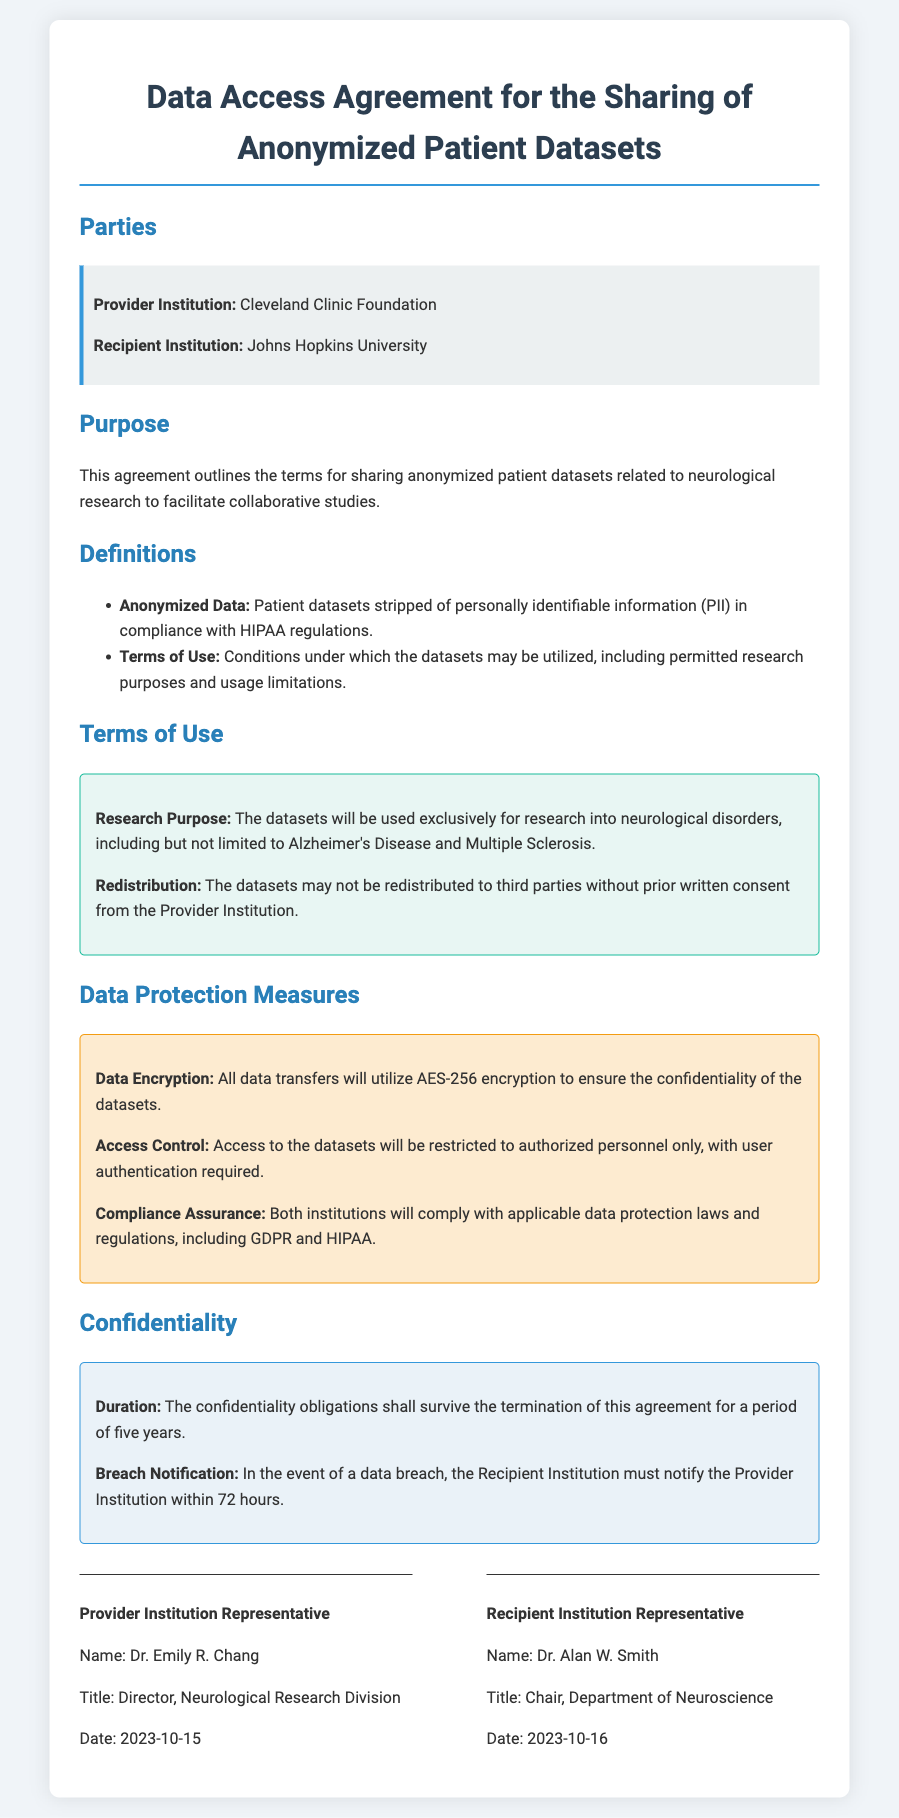What is the Provider Institution? The document identifies the organization providing the datasets as the Cleveland Clinic Foundation.
Answer: Cleveland Clinic Foundation Who is the Recipient Institution? The document specifies the organization receiving the datasets as Johns Hopkins University.
Answer: Johns Hopkins University What is the research purpose for the datasets? The document states that the datasets will be used exclusively for research into neurological disorders, including Alzheimer's Disease and Multiple Sclerosis.
Answer: Neurological disorders What is the encryption method used for data transfers? The document indicates that AES-256 encryption will be used to ensure confidentiality during data transfers.
Answer: AES-256 What is the duration of the confidentiality obligations? The document outlines that confidentiality obligations will last for a period of five years after the termination of the agreement.
Answer: Five years Who represents the Provider Institution? The document names Dr. Emily R. Chang as the representative for the Provider Institution along with her title.
Answer: Dr. Emily R. Chang When was the agreement signed by the Provider Institution representative? The document specifies that Dr. Emily R. Chang signed the agreement on the date 2023-10-15.
Answer: 2023-10-15 What must the Recipient Institution do in the event of a data breach? The document states that the Recipient Institution must notify the Provider Institution within 72 hours of a data breach.
Answer: 72 hours What compliance regulations are mentioned in relation to data protection? The document mentions compliance with GDPR and HIPAA as part of the data protection measures.
Answer: GDPR and HIPAA 